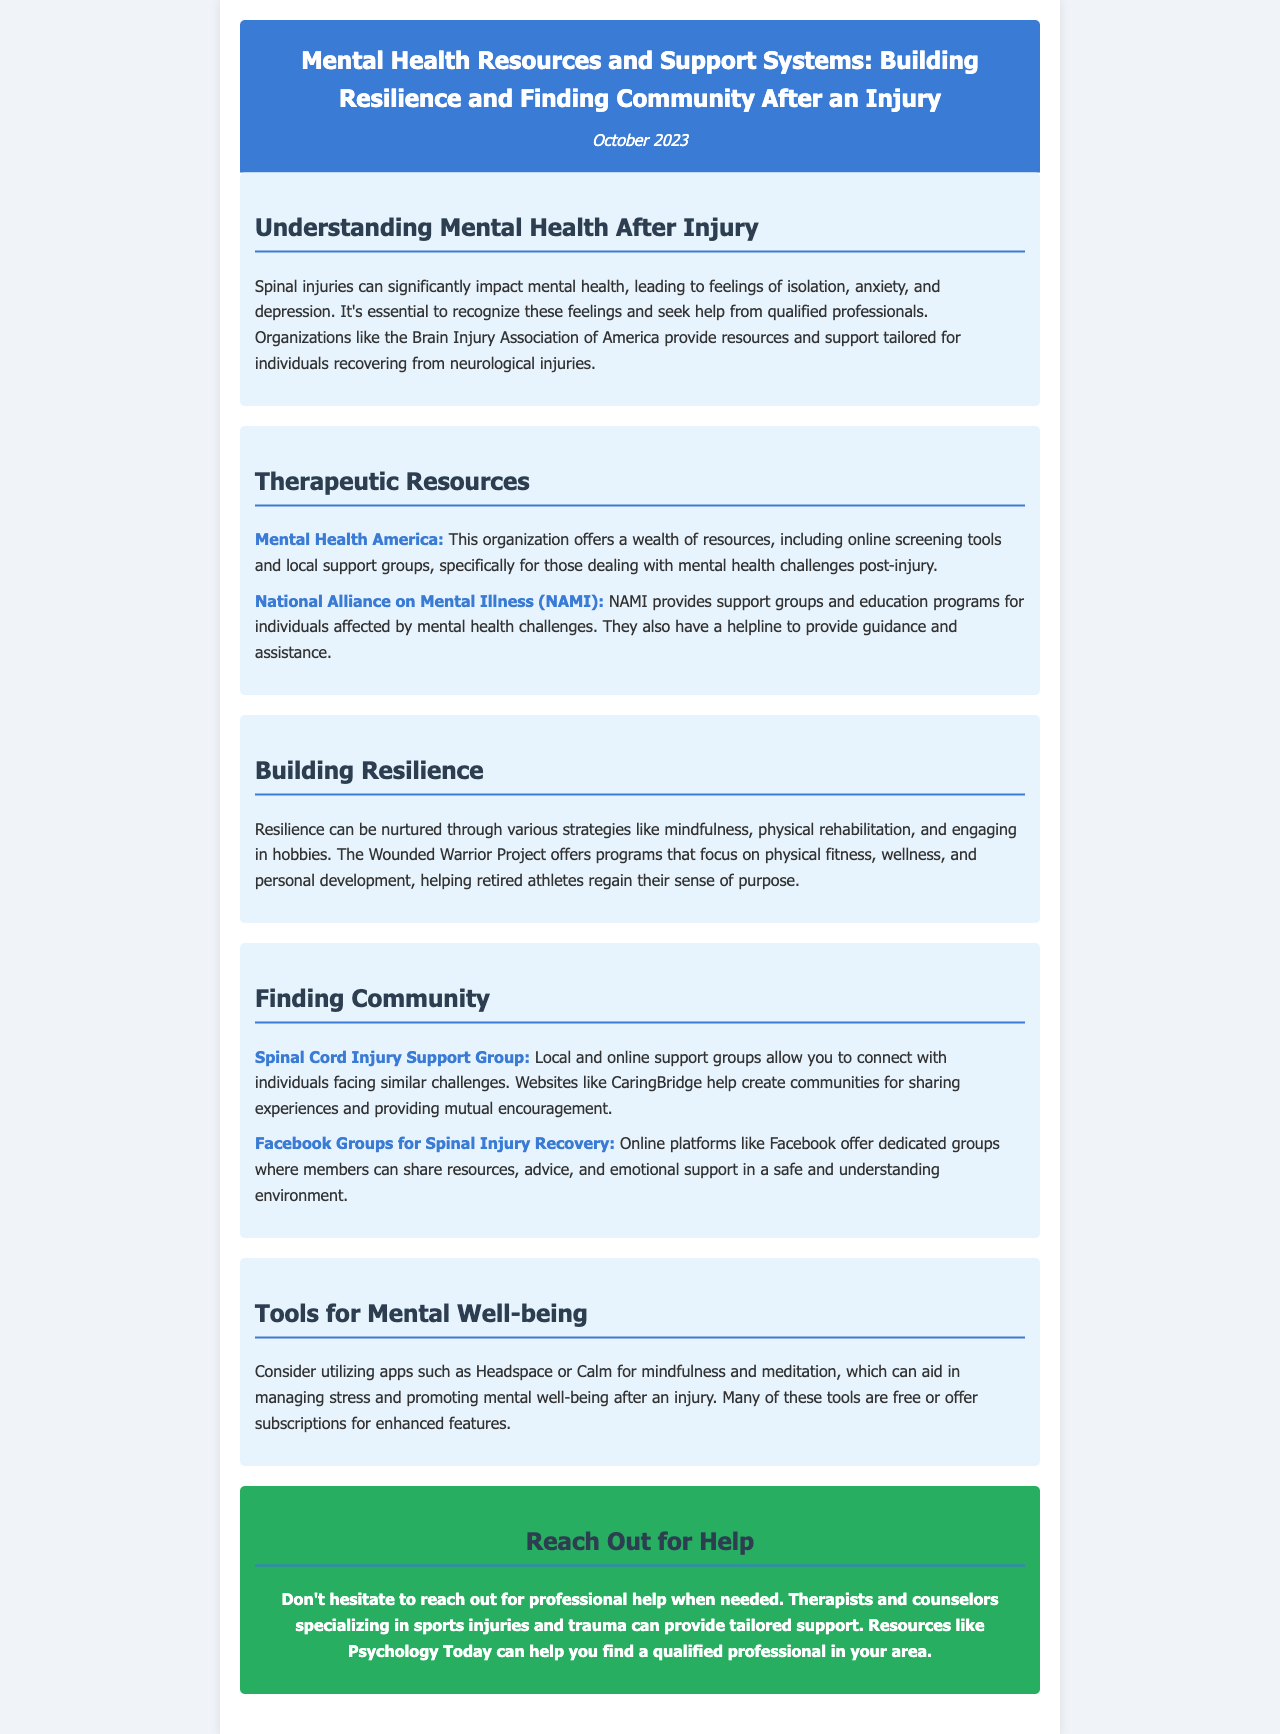What organization provides resources tailored for individuals recovering from neurological injuries? The organization mentioned in the document is the Brain Injury Association of America.
Answer: Brain Injury Association of America What is offered by Mental Health America? Mental Health America offers online screening tools and local support groups specifically for those dealing with mental health challenges post-injury.
Answer: Online screening tools and local support groups What are two strategies for building resilience mentioned in the document? The document highlights mindfulness and physical rehabilitation as strategies for building resilience.
Answer: Mindfulness, physical rehabilitation What can you use to manage stress and promote mental well-being after an injury? Apps such as Headspace or Calm are suggested for managing stress and promoting mental well-being.
Answer: Headspace or Calm Which resource can help connect individuals facing similar challenges? The Spinal Cord Injury Support Group is a resource that helps connect individuals facing similar challenges.
Answer: Spinal Cord Injury Support Group 